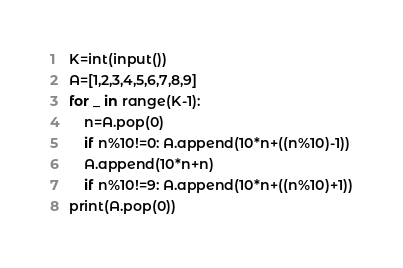<code> <loc_0><loc_0><loc_500><loc_500><_Python_>K=int(input())
A=[1,2,3,4,5,6,7,8,9]
for _ in range(K-1):
    n=A.pop(0)
    if n%10!=0: A.append(10*n+((n%10)-1))
    A.append(10*n+n)
    if n%10!=9: A.append(10*n+((n%10)+1))
print(A.pop(0))</code> 